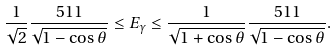Convert formula to latex. <formula><loc_0><loc_0><loc_500><loc_500>\frac { 1 } { \sqrt { 2 } } \frac { 5 1 1 } { \sqrt { 1 - \cos \theta } } \leq E _ { \gamma } \leq \frac { 1 } { \sqrt { 1 + \cos \theta } } \frac { 5 1 1 } { \sqrt { 1 - \cos \theta } } .</formula> 